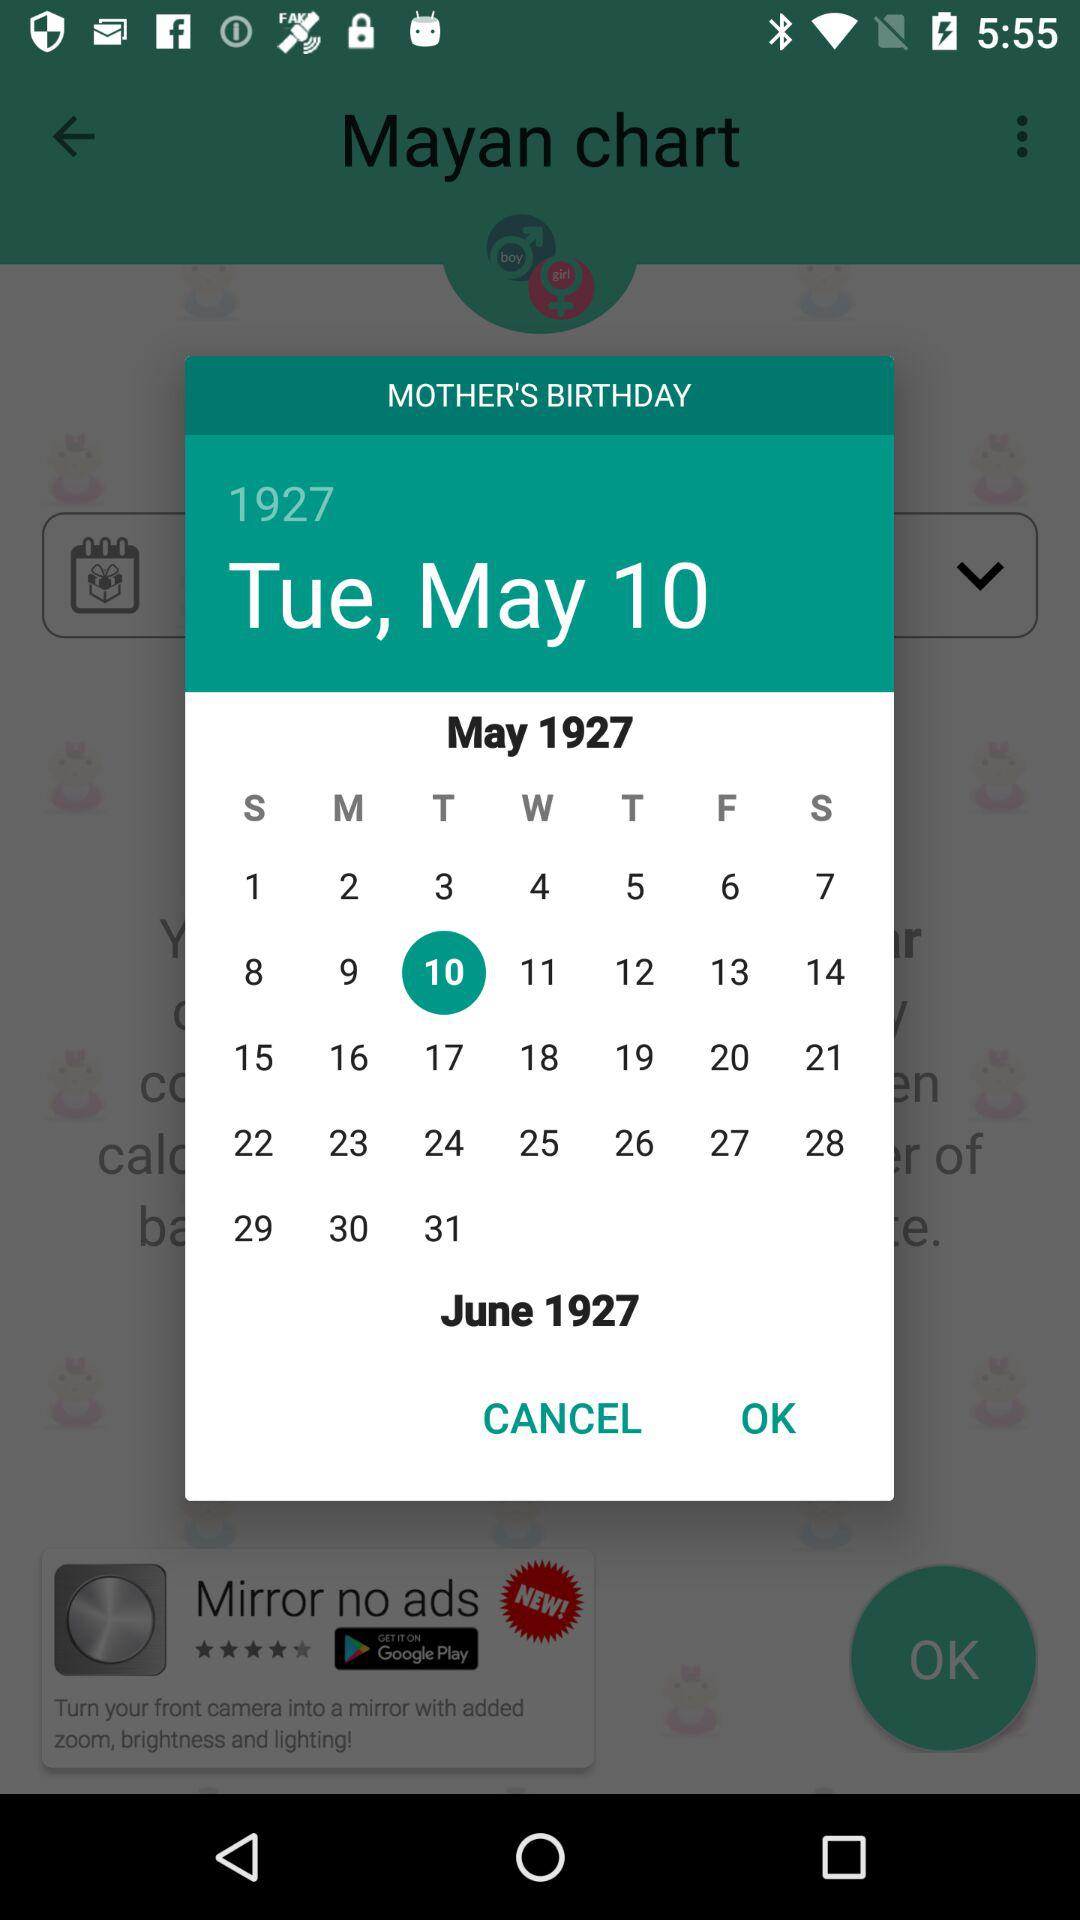What is the mother's year of birth? The year is 1927. 